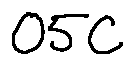Convert formula to latex. <formula><loc_0><loc_0><loc_500><loc_500>0 5 C</formula> 